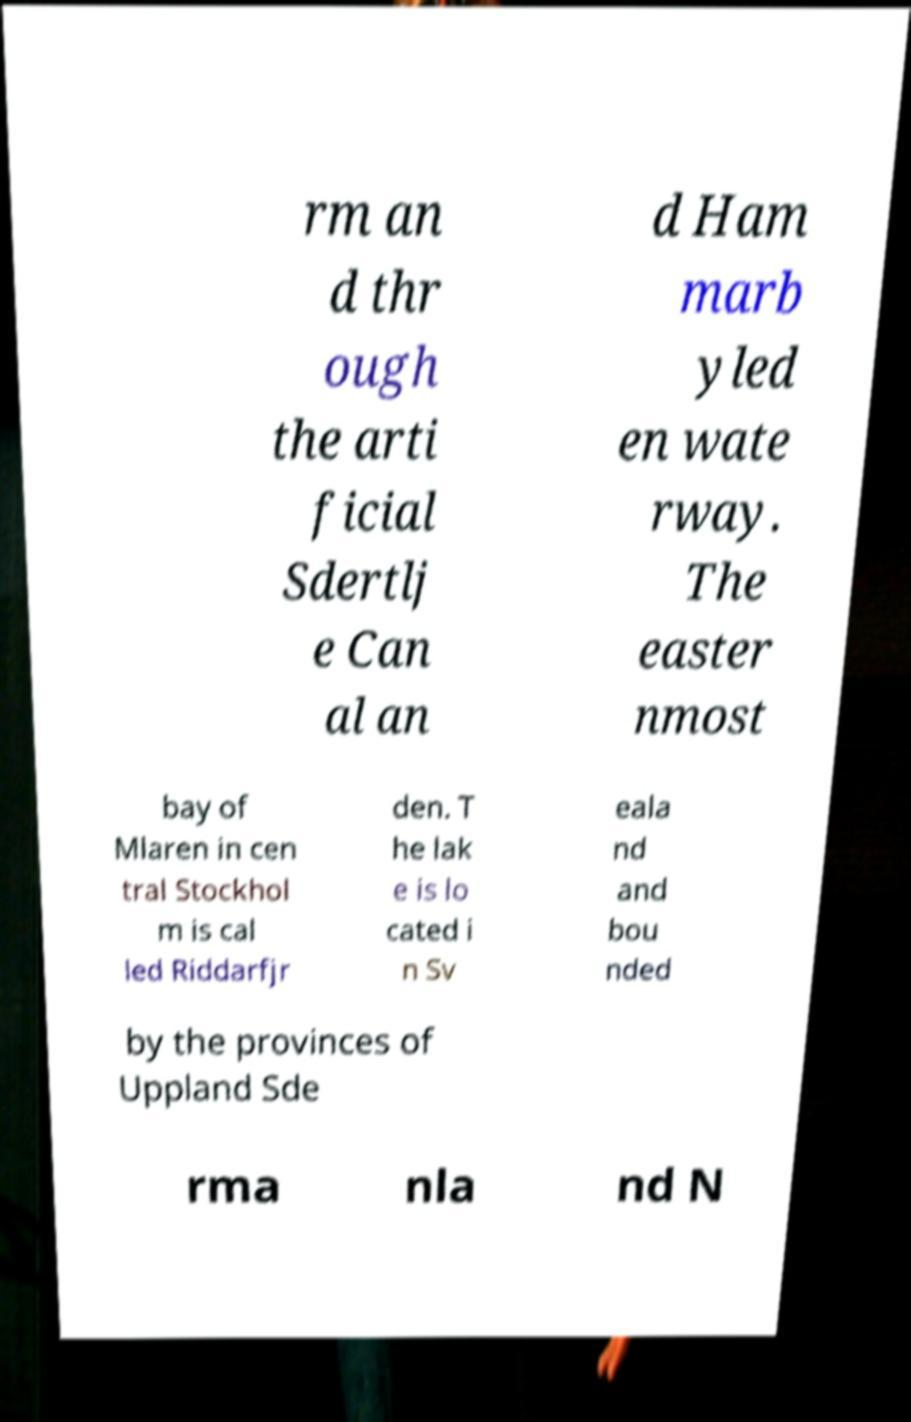Please identify and transcribe the text found in this image. rm an d thr ough the arti ficial Sdertlj e Can al an d Ham marb yled en wate rway. The easter nmost bay of Mlaren in cen tral Stockhol m is cal led Riddarfjr den. T he lak e is lo cated i n Sv eala nd and bou nded by the provinces of Uppland Sde rma nla nd N 